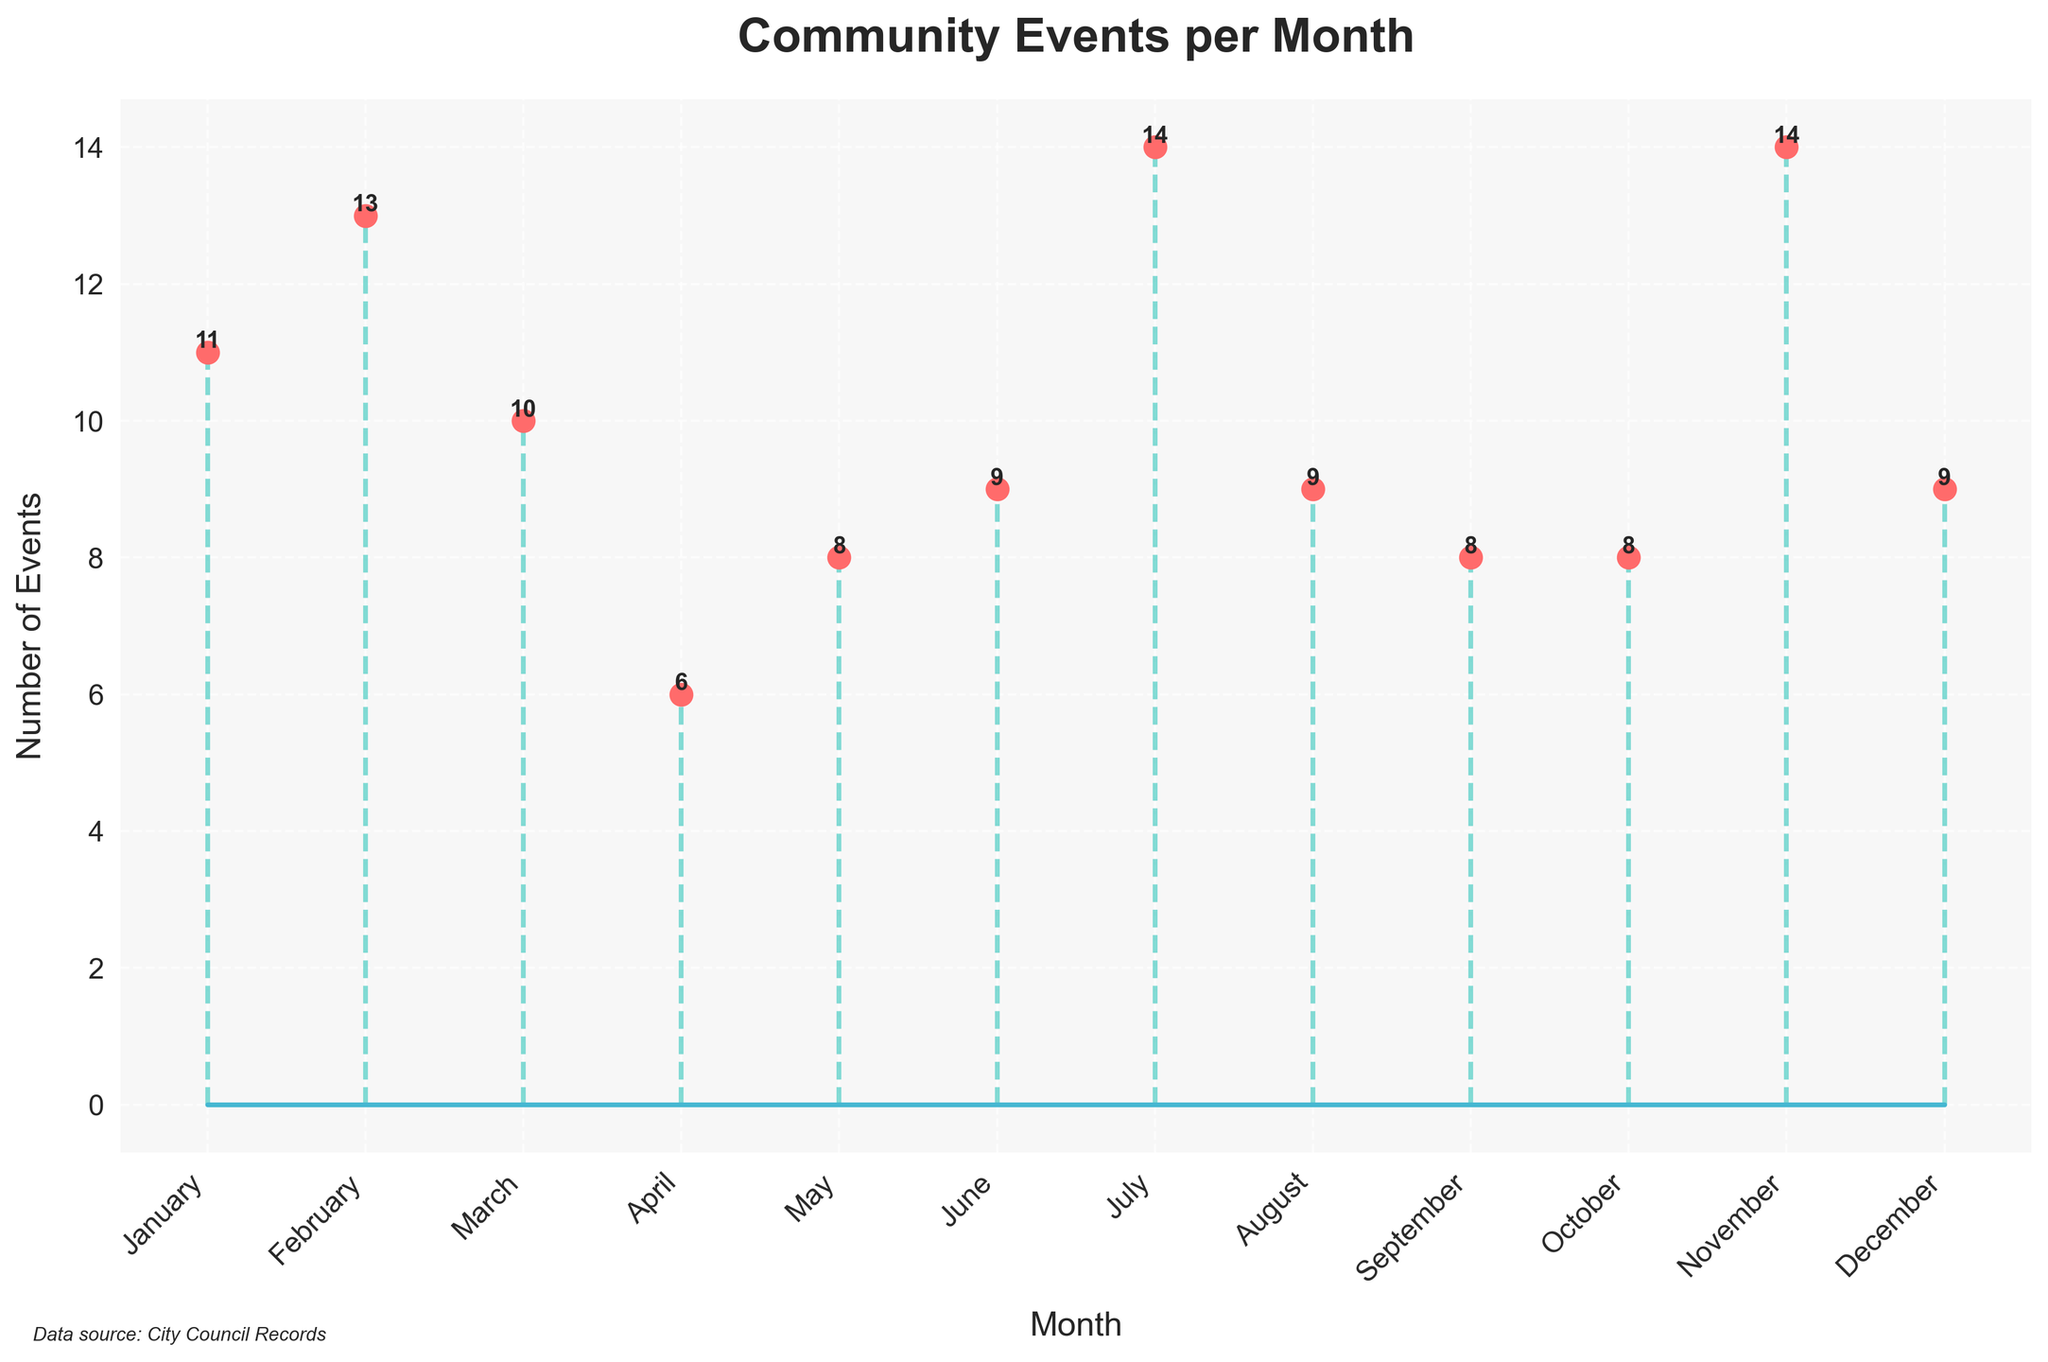What is the title of the plot? The title of the plot is displayed at the top of the figure, which reads 'Community Events per Month'.
Answer: Community Events per Month How many events were held in October? The number of community events for each month is shown as plotted points with labels above the points; for October, there are 14 events.
Answer: 14 Which month had the highest number of community events? Observing the height of the stem plots, April and October have the highest points, each with a total of 14 events.
Answer: April and October How many community events were held in January? By looking at the labeled data point for January on the x-axis, January had 8 community events.
Answer: 8 What is the sum of events held in February and March? The plot shows 6 events for February and 9 events for March. Summing these gives 6 + 9 = 15 events.
Answer: 15 How does the number of events in August compare to those in May? August had 13 events while May had 8 events, so August has more events compared to May.
Answer: August has more events What is the average number of events held per month? Sum the number of events for each month and divide by the number of months. Total events = 8 + 6 + 9 + 11 + 8 + 14 + 9 + 11 + 9 + 11 + 8 + 10 = 114. Average = 114/12 = 9.5 events.
Answer: 9.5 events Which months had less than 10 events? By checking each labeled point, January, February, May, June, July, September, and December had less than 10 events.
Answer: January, February, May, June, July, September, December What is the difference in the number of events between the month with the highest and lowest activities? The months with the highest activities are April and October (14 events), and the month with the lowest activities is February (6 events). Difference = 14 - 6 = 8 events.
Answer: 8 events 